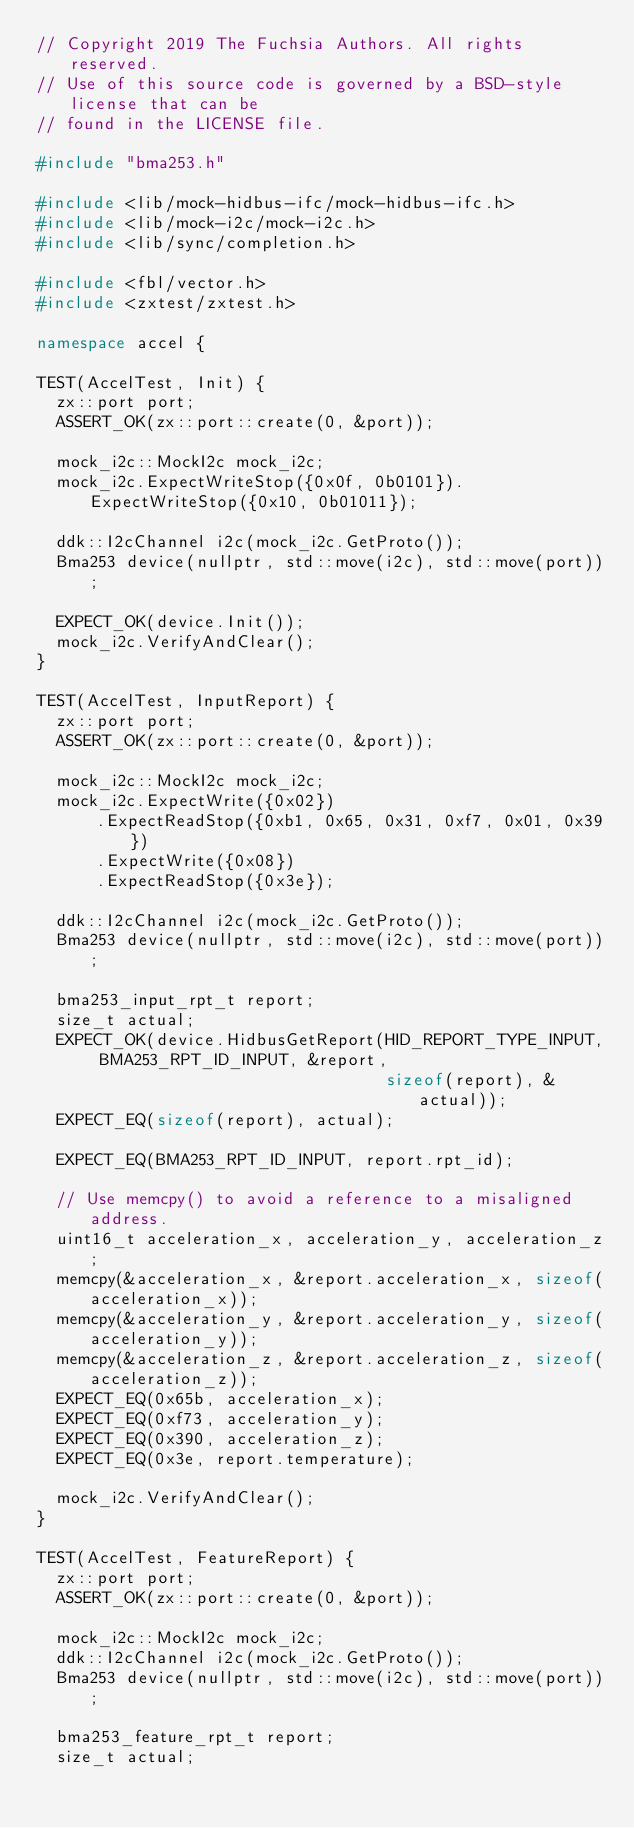Convert code to text. <code><loc_0><loc_0><loc_500><loc_500><_C++_>// Copyright 2019 The Fuchsia Authors. All rights reserved.
// Use of this source code is governed by a BSD-style license that can be
// found in the LICENSE file.

#include "bma253.h"

#include <lib/mock-hidbus-ifc/mock-hidbus-ifc.h>
#include <lib/mock-i2c/mock-i2c.h>
#include <lib/sync/completion.h>

#include <fbl/vector.h>
#include <zxtest/zxtest.h>

namespace accel {

TEST(AccelTest, Init) {
  zx::port port;
  ASSERT_OK(zx::port::create(0, &port));

  mock_i2c::MockI2c mock_i2c;
  mock_i2c.ExpectWriteStop({0x0f, 0b0101}).ExpectWriteStop({0x10, 0b01011});

  ddk::I2cChannel i2c(mock_i2c.GetProto());
  Bma253 device(nullptr, std::move(i2c), std::move(port));

  EXPECT_OK(device.Init());
  mock_i2c.VerifyAndClear();
}

TEST(AccelTest, InputReport) {
  zx::port port;
  ASSERT_OK(zx::port::create(0, &port));

  mock_i2c::MockI2c mock_i2c;
  mock_i2c.ExpectWrite({0x02})
      .ExpectReadStop({0xb1, 0x65, 0x31, 0xf7, 0x01, 0x39})
      .ExpectWrite({0x08})
      .ExpectReadStop({0x3e});

  ddk::I2cChannel i2c(mock_i2c.GetProto());
  Bma253 device(nullptr, std::move(i2c), std::move(port));

  bma253_input_rpt_t report;
  size_t actual;
  EXPECT_OK(device.HidbusGetReport(HID_REPORT_TYPE_INPUT, BMA253_RPT_ID_INPUT, &report,
                                   sizeof(report), &actual));
  EXPECT_EQ(sizeof(report), actual);

  EXPECT_EQ(BMA253_RPT_ID_INPUT, report.rpt_id);

  // Use memcpy() to avoid a reference to a misaligned address.
  uint16_t acceleration_x, acceleration_y, acceleration_z;
  memcpy(&acceleration_x, &report.acceleration_x, sizeof(acceleration_x));
  memcpy(&acceleration_y, &report.acceleration_y, sizeof(acceleration_y));
  memcpy(&acceleration_z, &report.acceleration_z, sizeof(acceleration_z));
  EXPECT_EQ(0x65b, acceleration_x);
  EXPECT_EQ(0xf73, acceleration_y);
  EXPECT_EQ(0x390, acceleration_z);
  EXPECT_EQ(0x3e, report.temperature);

  mock_i2c.VerifyAndClear();
}

TEST(AccelTest, FeatureReport) {
  zx::port port;
  ASSERT_OK(zx::port::create(0, &port));

  mock_i2c::MockI2c mock_i2c;
  ddk::I2cChannel i2c(mock_i2c.GetProto());
  Bma253 device(nullptr, std::move(i2c), std::move(port));

  bma253_feature_rpt_t report;
  size_t actual;
</code> 